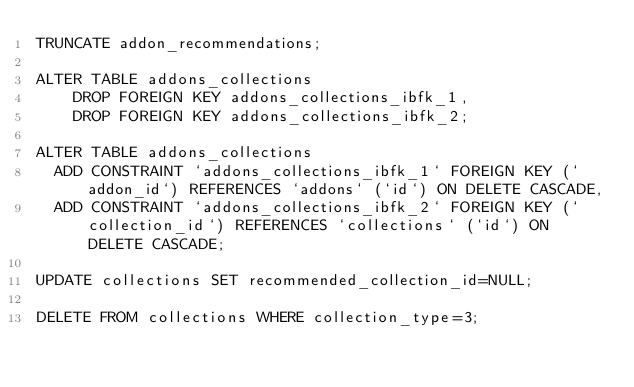<code> <loc_0><loc_0><loc_500><loc_500><_SQL_>TRUNCATE addon_recommendations;

ALTER TABLE addons_collections
    DROP FOREIGN KEY addons_collections_ibfk_1,
    DROP FOREIGN KEY addons_collections_ibfk_2;

ALTER TABLE addons_collections
  ADD CONSTRAINT `addons_collections_ibfk_1` FOREIGN KEY (`addon_id`) REFERENCES `addons` (`id`) ON DELETE CASCADE,
  ADD CONSTRAINT `addons_collections_ibfk_2` FOREIGN KEY (`collection_id`) REFERENCES `collections` (`id`) ON DELETE CASCADE;

UPDATE collections SET recommended_collection_id=NULL;

DELETE FROM collections WHERE collection_type=3;
</code> 